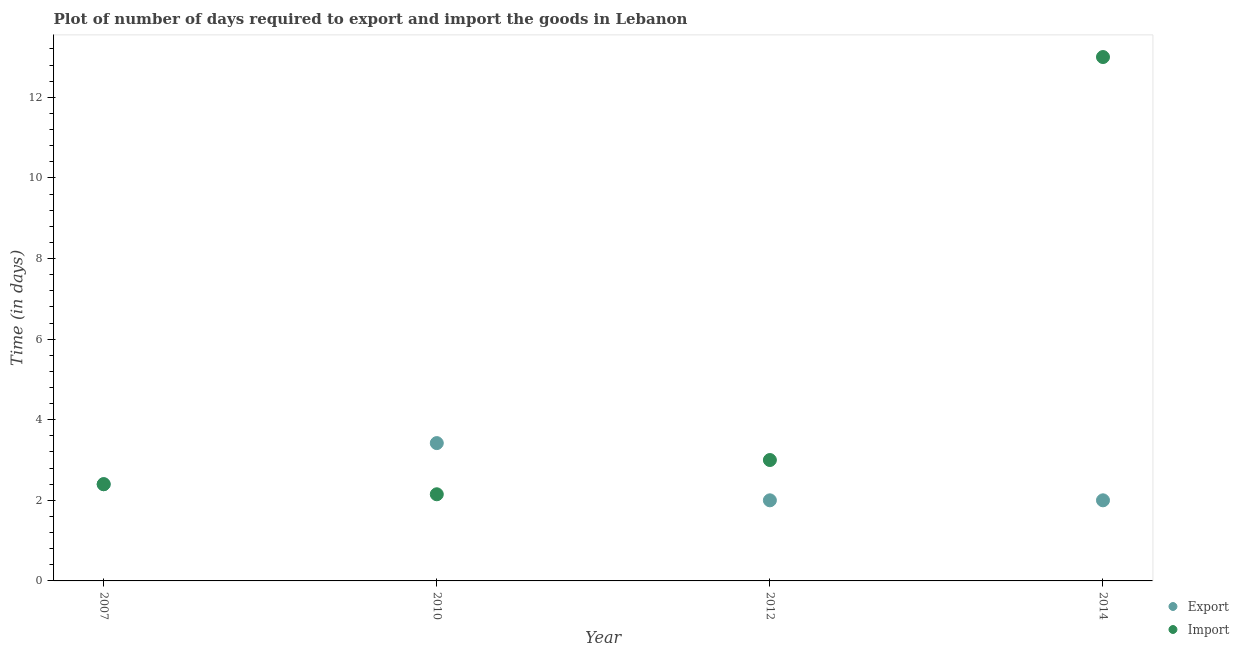How many different coloured dotlines are there?
Provide a succinct answer. 2. Is the number of dotlines equal to the number of legend labels?
Offer a terse response. Yes. What is the time required to import in 2007?
Provide a short and direct response. 2.4. In which year was the time required to export minimum?
Make the answer very short. 2012. What is the total time required to import in the graph?
Provide a succinct answer. 20.55. What is the difference between the time required to import in 2010 and that in 2014?
Keep it short and to the point. -10.85. What is the average time required to import per year?
Ensure brevity in your answer.  5.14. In the year 2010, what is the difference between the time required to export and time required to import?
Provide a succinct answer. 1.27. What is the ratio of the time required to import in 2010 to that in 2012?
Provide a succinct answer. 0.72. What is the difference between the highest and the lowest time required to export?
Keep it short and to the point. 1.42. In how many years, is the time required to import greater than the average time required to import taken over all years?
Keep it short and to the point. 1. Does the time required to export monotonically increase over the years?
Provide a short and direct response. No. Is the time required to export strictly less than the time required to import over the years?
Ensure brevity in your answer.  No. How many dotlines are there?
Offer a very short reply. 2. How many years are there in the graph?
Keep it short and to the point. 4. What is the difference between two consecutive major ticks on the Y-axis?
Give a very brief answer. 2. Are the values on the major ticks of Y-axis written in scientific E-notation?
Offer a terse response. No. Does the graph contain any zero values?
Provide a succinct answer. No. Where does the legend appear in the graph?
Your answer should be compact. Bottom right. How are the legend labels stacked?
Your answer should be very brief. Vertical. What is the title of the graph?
Ensure brevity in your answer.  Plot of number of days required to export and import the goods in Lebanon. Does "Malaria" appear as one of the legend labels in the graph?
Keep it short and to the point. No. What is the label or title of the Y-axis?
Make the answer very short. Time (in days). What is the Time (in days) of Export in 2007?
Ensure brevity in your answer.  2.4. What is the Time (in days) in Import in 2007?
Offer a terse response. 2.4. What is the Time (in days) in Export in 2010?
Your answer should be compact. 3.42. What is the Time (in days) in Import in 2010?
Provide a succinct answer. 2.15. What is the Time (in days) in Export in 2012?
Make the answer very short. 2. Across all years, what is the maximum Time (in days) in Export?
Ensure brevity in your answer.  3.42. Across all years, what is the maximum Time (in days) in Import?
Your response must be concise. 13. Across all years, what is the minimum Time (in days) of Import?
Offer a very short reply. 2.15. What is the total Time (in days) of Export in the graph?
Keep it short and to the point. 9.82. What is the total Time (in days) in Import in the graph?
Your answer should be compact. 20.55. What is the difference between the Time (in days) of Export in 2007 and that in 2010?
Ensure brevity in your answer.  -1.02. What is the difference between the Time (in days) of Import in 2007 and that in 2010?
Make the answer very short. 0.25. What is the difference between the Time (in days) of Export in 2007 and that in 2014?
Keep it short and to the point. 0.4. What is the difference between the Time (in days) in Export in 2010 and that in 2012?
Keep it short and to the point. 1.42. What is the difference between the Time (in days) in Import in 2010 and that in 2012?
Give a very brief answer. -0.85. What is the difference between the Time (in days) in Export in 2010 and that in 2014?
Ensure brevity in your answer.  1.42. What is the difference between the Time (in days) in Import in 2010 and that in 2014?
Provide a short and direct response. -10.85. What is the difference between the Time (in days) in Import in 2012 and that in 2014?
Your answer should be very brief. -10. What is the difference between the Time (in days) of Export in 2010 and the Time (in days) of Import in 2012?
Give a very brief answer. 0.42. What is the difference between the Time (in days) in Export in 2010 and the Time (in days) in Import in 2014?
Your response must be concise. -9.58. What is the average Time (in days) of Export per year?
Offer a terse response. 2.46. What is the average Time (in days) of Import per year?
Provide a short and direct response. 5.14. In the year 2007, what is the difference between the Time (in days) of Export and Time (in days) of Import?
Make the answer very short. 0. In the year 2010, what is the difference between the Time (in days) in Export and Time (in days) in Import?
Keep it short and to the point. 1.27. In the year 2014, what is the difference between the Time (in days) of Export and Time (in days) of Import?
Give a very brief answer. -11. What is the ratio of the Time (in days) of Export in 2007 to that in 2010?
Provide a short and direct response. 0.7. What is the ratio of the Time (in days) of Import in 2007 to that in 2010?
Ensure brevity in your answer.  1.12. What is the ratio of the Time (in days) in Export in 2007 to that in 2012?
Provide a succinct answer. 1.2. What is the ratio of the Time (in days) in Import in 2007 to that in 2012?
Give a very brief answer. 0.8. What is the ratio of the Time (in days) in Import in 2007 to that in 2014?
Keep it short and to the point. 0.18. What is the ratio of the Time (in days) of Export in 2010 to that in 2012?
Ensure brevity in your answer.  1.71. What is the ratio of the Time (in days) in Import in 2010 to that in 2012?
Offer a very short reply. 0.72. What is the ratio of the Time (in days) in Export in 2010 to that in 2014?
Make the answer very short. 1.71. What is the ratio of the Time (in days) in Import in 2010 to that in 2014?
Provide a succinct answer. 0.17. What is the ratio of the Time (in days) in Import in 2012 to that in 2014?
Keep it short and to the point. 0.23. What is the difference between the highest and the lowest Time (in days) of Export?
Your answer should be compact. 1.42. What is the difference between the highest and the lowest Time (in days) in Import?
Provide a short and direct response. 10.85. 